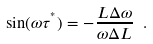Convert formula to latex. <formula><loc_0><loc_0><loc_500><loc_500>\sin ( \omega \tau ^ { ^ { * } } ) = - \frac { L \Delta \omega } { \omega \Delta L } \ .</formula> 